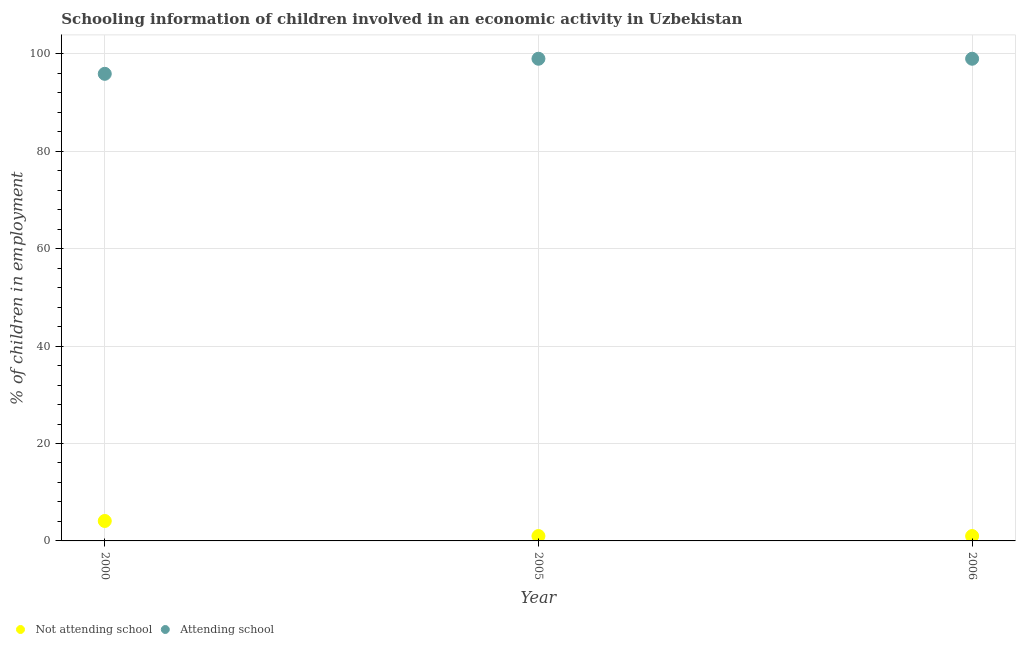What is the percentage of employed children who are not attending school in 2000?
Your response must be concise. 4.1. Across all years, what is the maximum percentage of employed children who are not attending school?
Provide a short and direct response. 4.1. Across all years, what is the minimum percentage of employed children who are attending school?
Your answer should be compact. 95.9. In which year was the percentage of employed children who are not attending school maximum?
Offer a very short reply. 2000. In which year was the percentage of employed children who are attending school minimum?
Your answer should be very brief. 2000. What is the total percentage of employed children who are attending school in the graph?
Provide a succinct answer. 293.9. What is the difference between the percentage of employed children who are not attending school in 2000 and that in 2006?
Offer a very short reply. 3.1. What is the difference between the percentage of employed children who are attending school in 2006 and the percentage of employed children who are not attending school in 2005?
Offer a terse response. 98. What is the average percentage of employed children who are not attending school per year?
Provide a short and direct response. 2.03. In the year 2006, what is the difference between the percentage of employed children who are attending school and percentage of employed children who are not attending school?
Provide a short and direct response. 98. What is the ratio of the percentage of employed children who are not attending school in 2000 to that in 2006?
Make the answer very short. 4.1. Is the percentage of employed children who are attending school in 2005 less than that in 2006?
Provide a short and direct response. No. What is the difference between the highest and the second highest percentage of employed children who are attending school?
Offer a very short reply. 0. What is the difference between the highest and the lowest percentage of employed children who are not attending school?
Provide a succinct answer. 3.1. Does the percentage of employed children who are not attending school monotonically increase over the years?
Ensure brevity in your answer.  No. Is the percentage of employed children who are not attending school strictly less than the percentage of employed children who are attending school over the years?
Keep it short and to the point. Yes. How many legend labels are there?
Keep it short and to the point. 2. What is the title of the graph?
Keep it short and to the point. Schooling information of children involved in an economic activity in Uzbekistan. What is the label or title of the Y-axis?
Keep it short and to the point. % of children in employment. What is the % of children in employment in Not attending school in 2000?
Keep it short and to the point. 4.1. What is the % of children in employment of Attending school in 2000?
Your answer should be very brief. 95.9. Across all years, what is the maximum % of children in employment in Not attending school?
Offer a very short reply. 4.1. Across all years, what is the maximum % of children in employment of Attending school?
Offer a very short reply. 99. Across all years, what is the minimum % of children in employment of Attending school?
Provide a succinct answer. 95.9. What is the total % of children in employment in Not attending school in the graph?
Give a very brief answer. 6.1. What is the total % of children in employment of Attending school in the graph?
Make the answer very short. 293.9. What is the difference between the % of children in employment in Not attending school in 2000 and that in 2005?
Keep it short and to the point. 3.1. What is the difference between the % of children in employment in Attending school in 2000 and that in 2005?
Provide a short and direct response. -3.1. What is the difference between the % of children in employment of Not attending school in 2000 and that in 2006?
Provide a short and direct response. 3.1. What is the difference between the % of children in employment of Attending school in 2000 and that in 2006?
Offer a very short reply. -3.1. What is the difference between the % of children in employment in Not attending school in 2005 and that in 2006?
Keep it short and to the point. 0. What is the difference between the % of children in employment of Attending school in 2005 and that in 2006?
Offer a terse response. 0. What is the difference between the % of children in employment in Not attending school in 2000 and the % of children in employment in Attending school in 2005?
Ensure brevity in your answer.  -94.9. What is the difference between the % of children in employment of Not attending school in 2000 and the % of children in employment of Attending school in 2006?
Ensure brevity in your answer.  -94.9. What is the difference between the % of children in employment of Not attending school in 2005 and the % of children in employment of Attending school in 2006?
Make the answer very short. -98. What is the average % of children in employment in Not attending school per year?
Provide a short and direct response. 2.03. What is the average % of children in employment in Attending school per year?
Provide a succinct answer. 97.97. In the year 2000, what is the difference between the % of children in employment in Not attending school and % of children in employment in Attending school?
Ensure brevity in your answer.  -91.81. In the year 2005, what is the difference between the % of children in employment in Not attending school and % of children in employment in Attending school?
Make the answer very short. -98. In the year 2006, what is the difference between the % of children in employment of Not attending school and % of children in employment of Attending school?
Provide a succinct answer. -98. What is the ratio of the % of children in employment in Not attending school in 2000 to that in 2005?
Give a very brief answer. 4.1. What is the ratio of the % of children in employment in Attending school in 2000 to that in 2005?
Provide a short and direct response. 0.97. What is the ratio of the % of children in employment in Not attending school in 2000 to that in 2006?
Provide a short and direct response. 4.1. What is the ratio of the % of children in employment in Attending school in 2000 to that in 2006?
Make the answer very short. 0.97. What is the difference between the highest and the second highest % of children in employment of Not attending school?
Your response must be concise. 3.1. What is the difference between the highest and the lowest % of children in employment in Not attending school?
Provide a short and direct response. 3.1. What is the difference between the highest and the lowest % of children in employment of Attending school?
Ensure brevity in your answer.  3.1. 